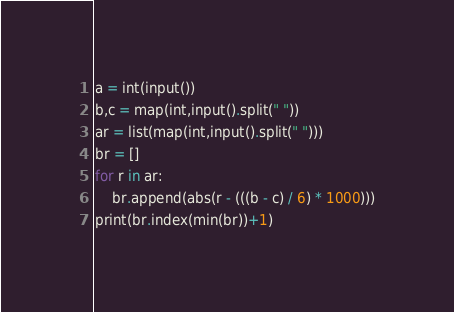<code> <loc_0><loc_0><loc_500><loc_500><_Python_>a = int(input())
b,c = map(int,input().split(" "))
ar = list(map(int,input().split(" ")))
br = []
for r in ar:
    br.append(abs(r - (((b - c) / 6) * 1000)))
print(br.index(min(br))+1)</code> 